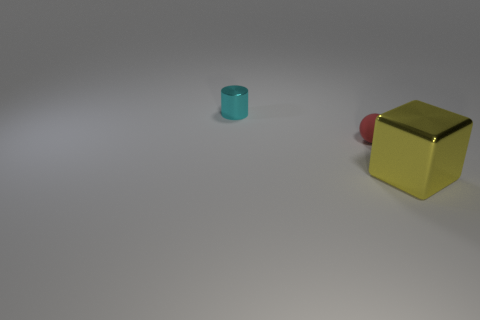There is a metal thing that is left of the thing to the right of the tiny red sphere; what color is it?
Ensure brevity in your answer.  Cyan. How many big metallic blocks are to the left of the metallic thing that is behind the shiny object that is right of the tiny metallic thing?
Offer a very short reply. 0. There is a small thing that is behind the matte object; does it have the same shape as the metal thing that is in front of the tiny cyan metal cylinder?
Your answer should be very brief. No. What number of objects are either big red shiny cylinders or large yellow shiny cubes?
Provide a succinct answer. 1. What material is the small object in front of the shiny thing left of the big yellow metallic block?
Give a very brief answer. Rubber. Are there any large spheres of the same color as the small metallic object?
Offer a terse response. No. The cylinder that is the same size as the red ball is what color?
Your answer should be very brief. Cyan. The tiny thing to the right of the metallic object that is on the left side of the shiny thing that is in front of the small rubber sphere is made of what material?
Give a very brief answer. Rubber. Is the color of the large block the same as the small thing in front of the cylinder?
Your answer should be very brief. No. What number of things are either metal objects that are left of the yellow metal block or shiny objects behind the tiny red matte ball?
Give a very brief answer. 1. 